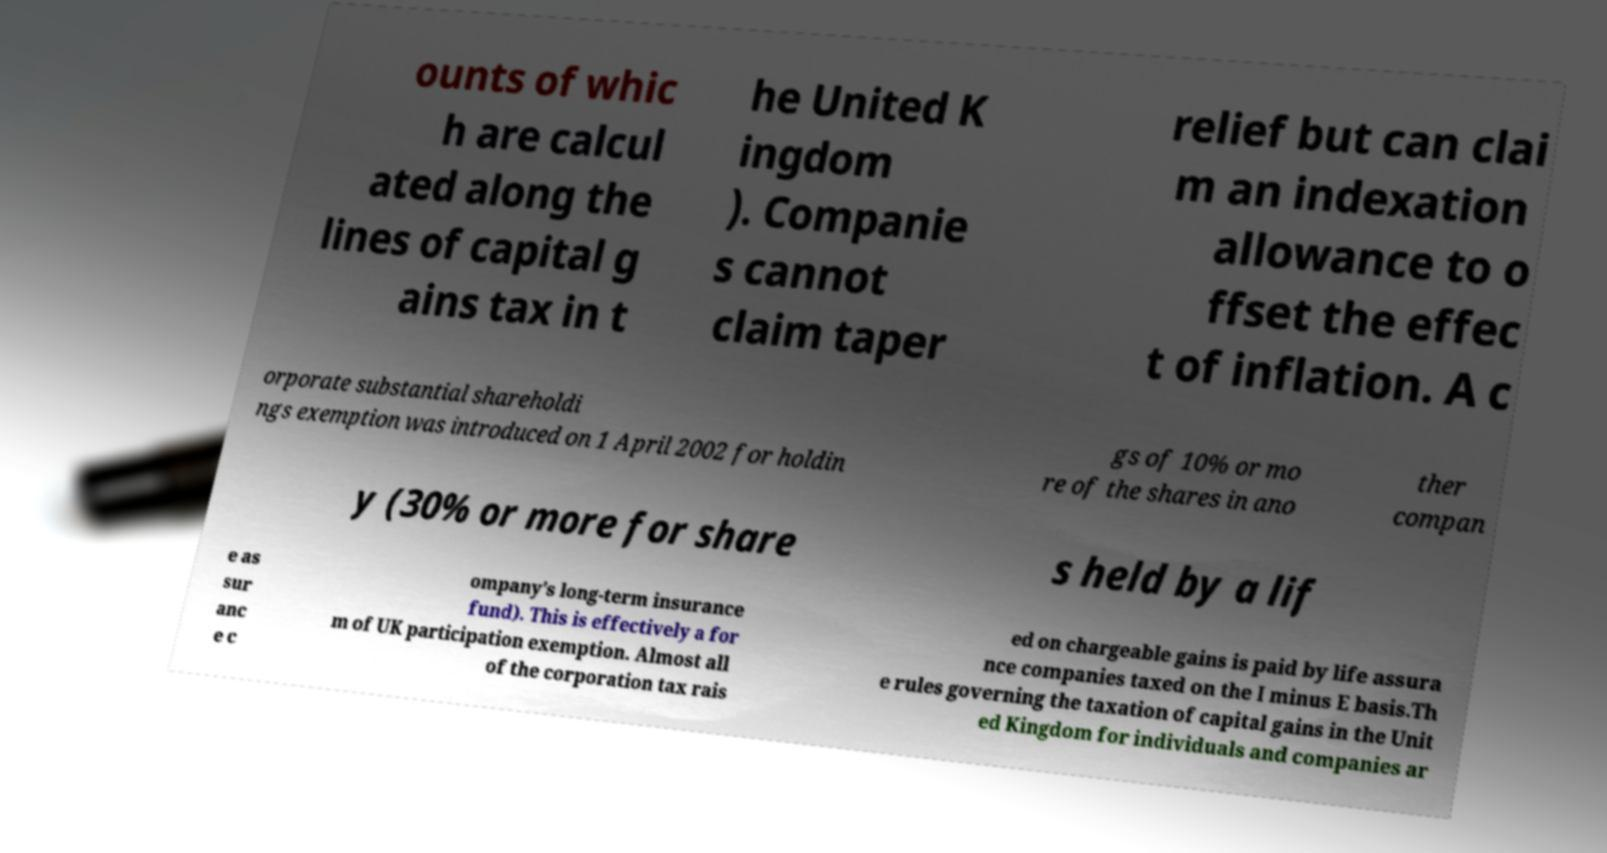There's text embedded in this image that I need extracted. Can you transcribe it verbatim? ounts of whic h are calcul ated along the lines of capital g ains tax in t he United K ingdom ). Companie s cannot claim taper relief but can clai m an indexation allowance to o ffset the effec t of inflation. A c orporate substantial shareholdi ngs exemption was introduced on 1 April 2002 for holdin gs of 10% or mo re of the shares in ano ther compan y (30% or more for share s held by a lif e as sur anc e c ompany's long-term insurance fund). This is effectively a for m of UK participation exemption. Almost all of the corporation tax rais ed on chargeable gains is paid by life assura nce companies taxed on the I minus E basis.Th e rules governing the taxation of capital gains in the Unit ed Kingdom for individuals and companies ar 